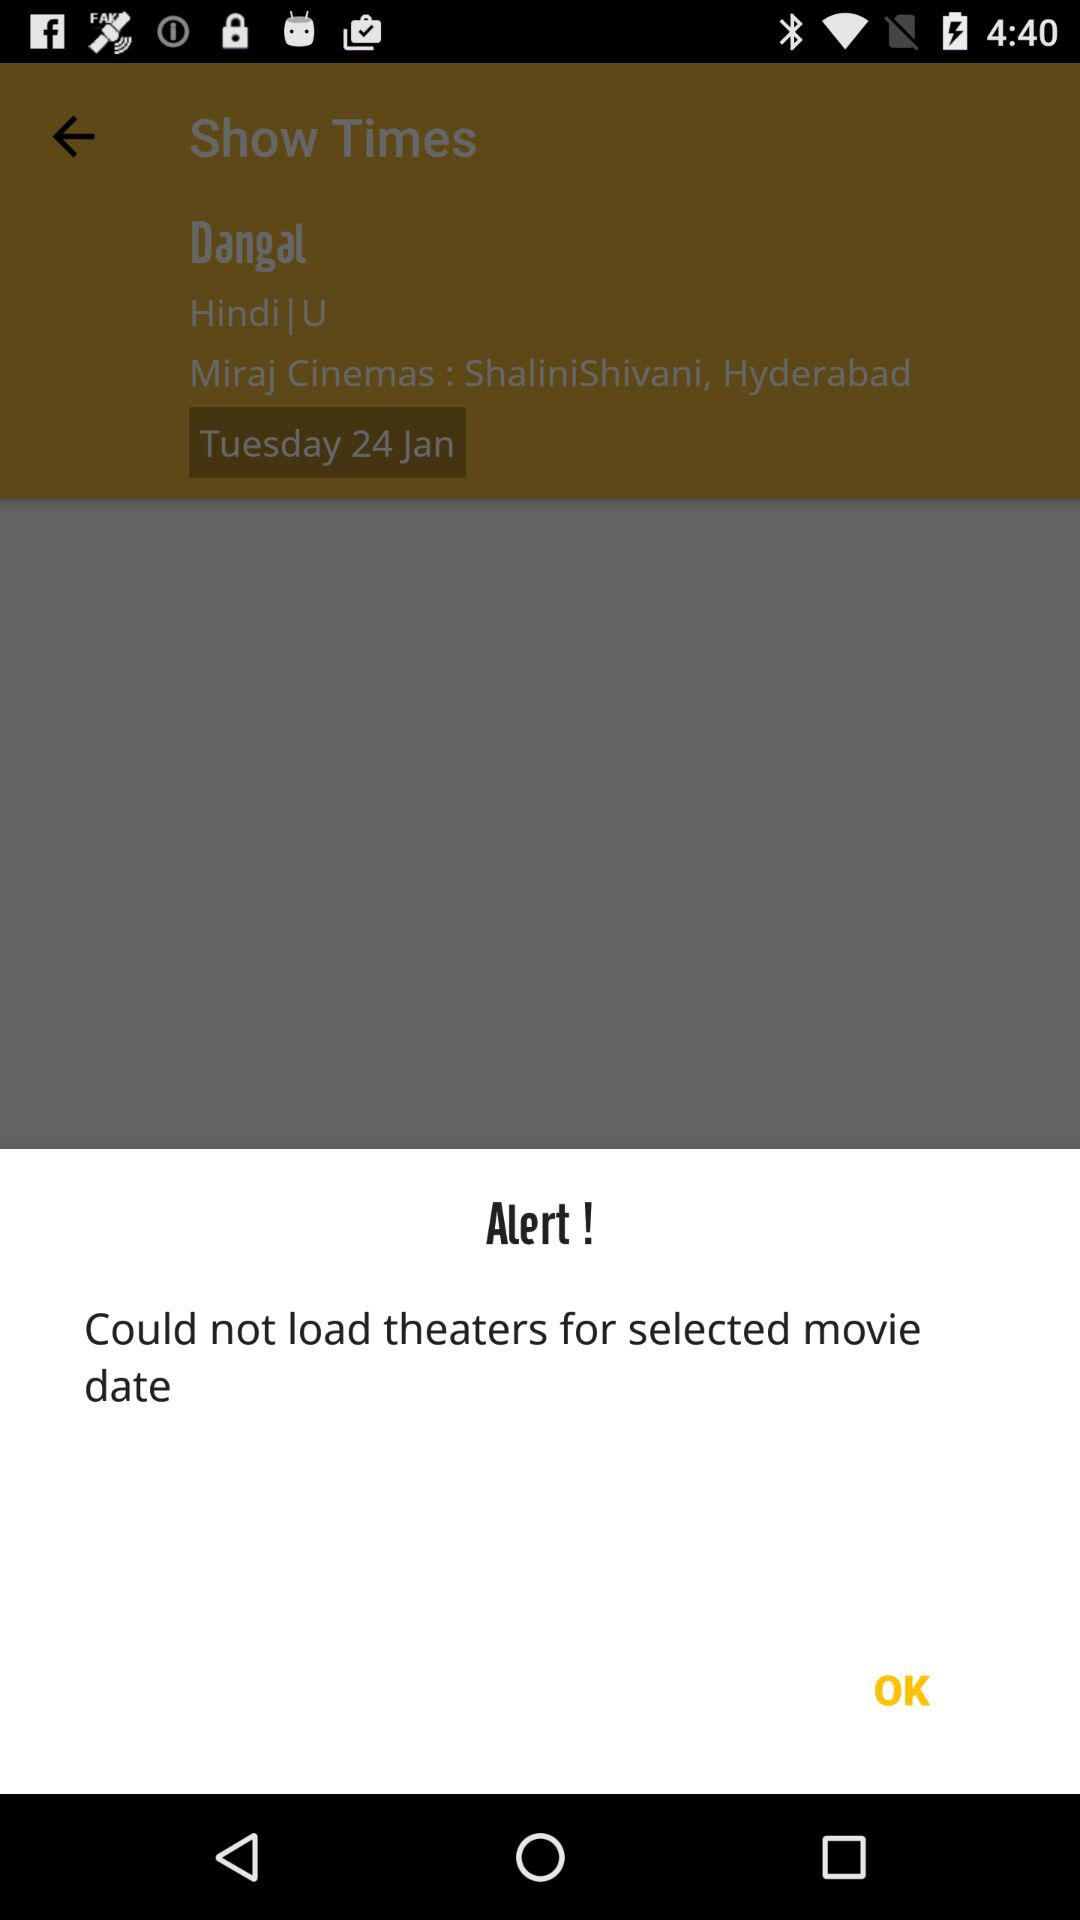What cinema is chosen for booking? For booking, Miraj Cinema is chosen. 